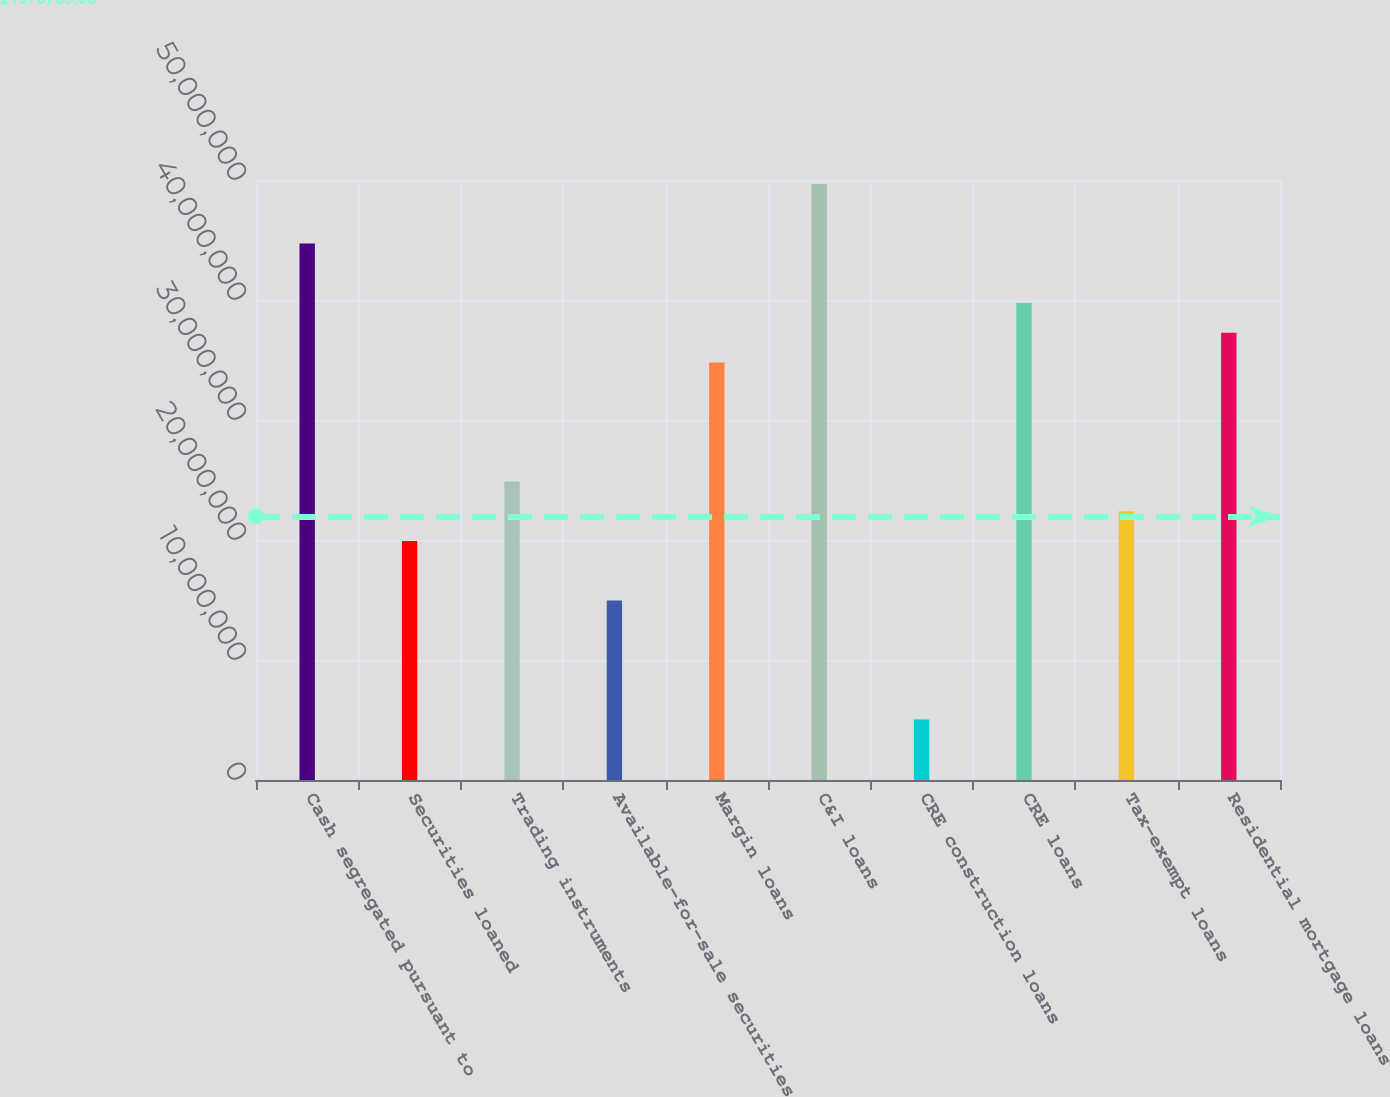<chart> <loc_0><loc_0><loc_500><loc_500><bar_chart><fcel>Cash segregated pursuant to<fcel>Securities loaned<fcel>Trading instruments<fcel>Available-for-sale securities<fcel>Margin loans<fcel>C&I loans<fcel>CRE construction loans<fcel>CRE loans<fcel>Tax-exempt loans<fcel>Residential mortgage loans<nl><fcel>4.47101e+07<fcel>1.99154e+07<fcel>2.48743e+07<fcel>1.49565e+07<fcel>3.47922e+07<fcel>4.96691e+07<fcel>5.03856e+06<fcel>3.97512e+07<fcel>2.23949e+07<fcel>3.72717e+07<nl></chart> 